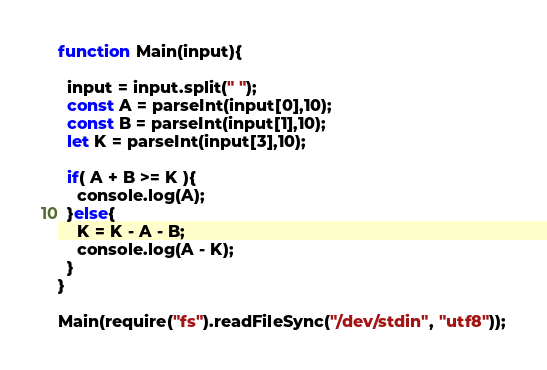<code> <loc_0><loc_0><loc_500><loc_500><_JavaScript_>function Main(input){
  
  input = input.split(" ");
  const A = parseInt(input[0],10);
  const B = parseInt(input[1],10);
  let K = parseInt(input[3],10);
  
  if( A + B >= K ){
  	console.log(A);
  }else{
  	K = K - A - B;
    console.log(A - K);
  }
}
 
Main(require("fs").readFileSync("/dev/stdin", "utf8"));</code> 